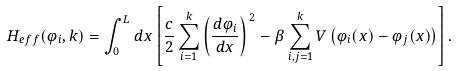Convert formula to latex. <formula><loc_0><loc_0><loc_500><loc_500>H _ { e f f } ( \varphi _ { i } , k ) = \int _ { 0 } ^ { L } d x \left [ \frac { c } { 2 } \sum _ { i = 1 } ^ { k } \left ( \frac { d \varphi _ { i } } { d x } \right ) ^ { \, 2 } - \beta \sum _ { i , j = 1 } ^ { k } V \left ( \varphi _ { i } ( x ) - \varphi _ { j } ( x ) \right ) \right ] .</formula> 